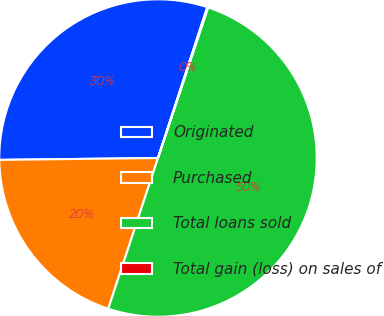Convert chart. <chart><loc_0><loc_0><loc_500><loc_500><pie_chart><fcel>Originated<fcel>Purchased<fcel>Total loans sold<fcel>Total gain (loss) on sales of<nl><fcel>30.21%<fcel>19.74%<fcel>49.96%<fcel>0.09%<nl></chart> 